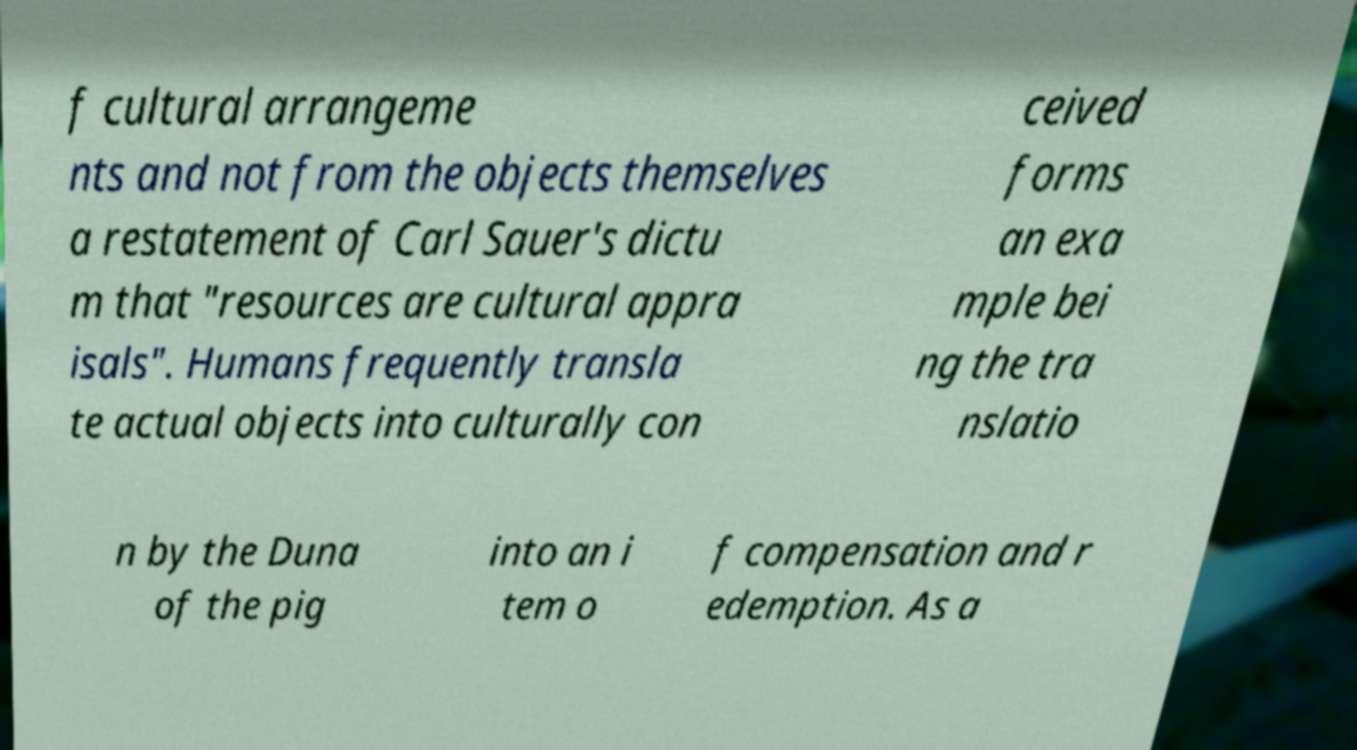Could you assist in decoding the text presented in this image and type it out clearly? f cultural arrangeme nts and not from the objects themselves a restatement of Carl Sauer's dictu m that "resources are cultural appra isals". Humans frequently transla te actual objects into culturally con ceived forms an exa mple bei ng the tra nslatio n by the Duna of the pig into an i tem o f compensation and r edemption. As a 